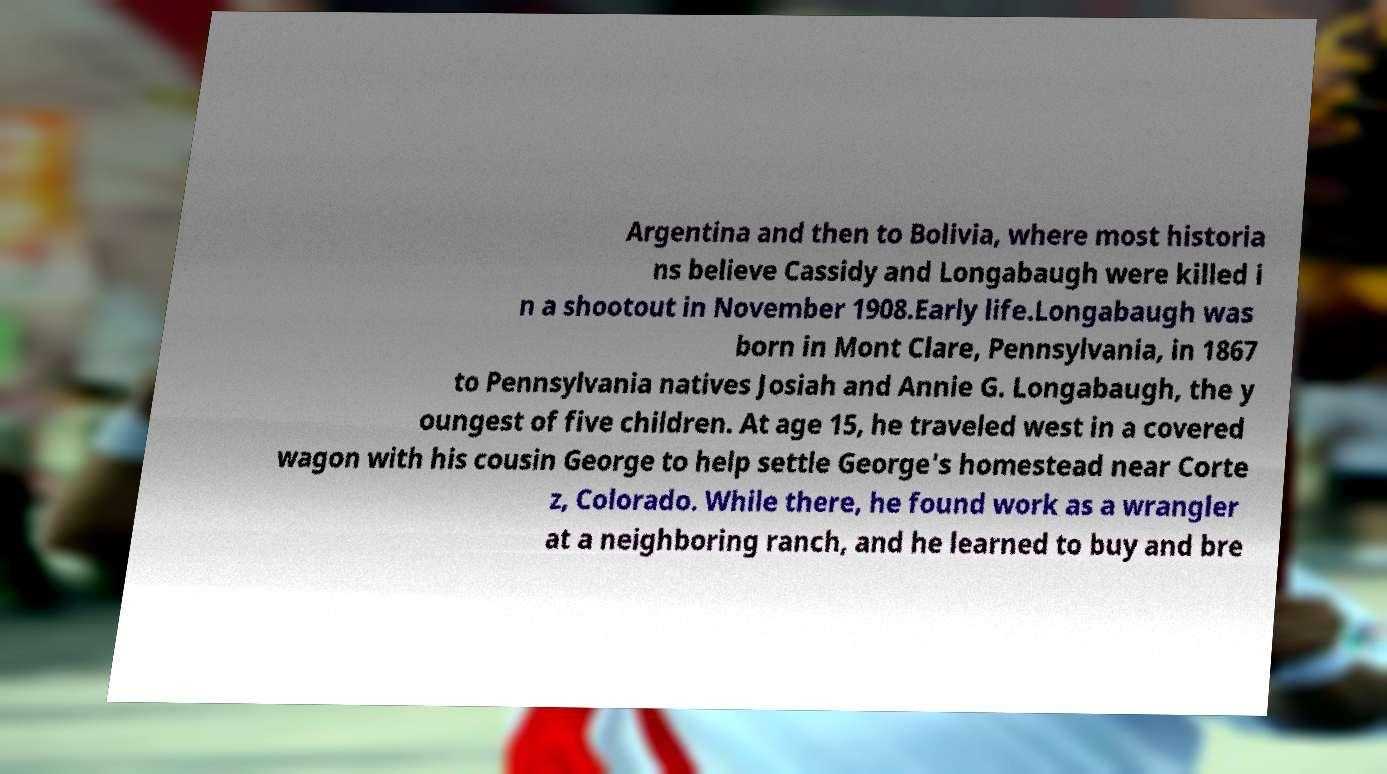Can you accurately transcribe the text from the provided image for me? Argentina and then to Bolivia, where most historia ns believe Cassidy and Longabaugh were killed i n a shootout in November 1908.Early life.Longabaugh was born in Mont Clare, Pennsylvania, in 1867 to Pennsylvania natives Josiah and Annie G. Longabaugh, the y oungest of five children. At age 15, he traveled west in a covered wagon with his cousin George to help settle George's homestead near Corte z, Colorado. While there, he found work as a wrangler at a neighboring ranch, and he learned to buy and bre 